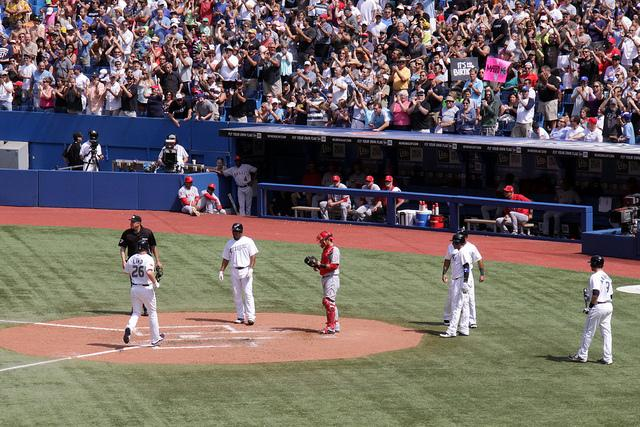What position is the man in red kneepads on the field playing? Please explain your reasoning. catcher. In the game of baseball, this is the only position player that wears a chest protector and shin guards along with a mask and a special mitt as he works crouched down behind the batter catching and calling pitches. 